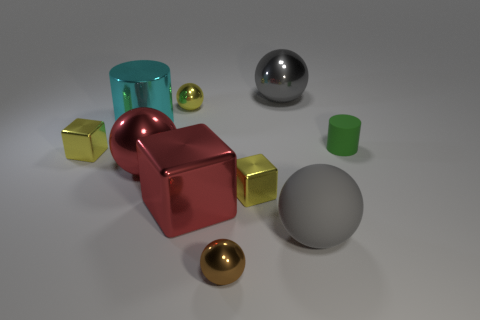What number of things are big cyan matte cubes or large metal cubes?
Your answer should be very brief. 1. How many brown things have the same material as the large block?
Ensure brevity in your answer.  1. What size is the yellow metallic object that is the same shape as the brown thing?
Make the answer very short. Small. There is a tiny yellow metal sphere; are there any yellow balls in front of it?
Your answer should be very brief. No. What is the material of the big cube?
Provide a succinct answer. Metal. There is a tiny ball in front of the small green matte cylinder; is it the same color as the rubber cylinder?
Provide a succinct answer. No. Are there any other things that have the same shape as the small matte object?
Your response must be concise. Yes. What color is the shiny object that is the same shape as the tiny matte thing?
Provide a short and direct response. Cyan. There is a large gray sphere that is behind the large cyan object; what material is it?
Ensure brevity in your answer.  Metal. What is the color of the matte cylinder?
Make the answer very short. Green. 